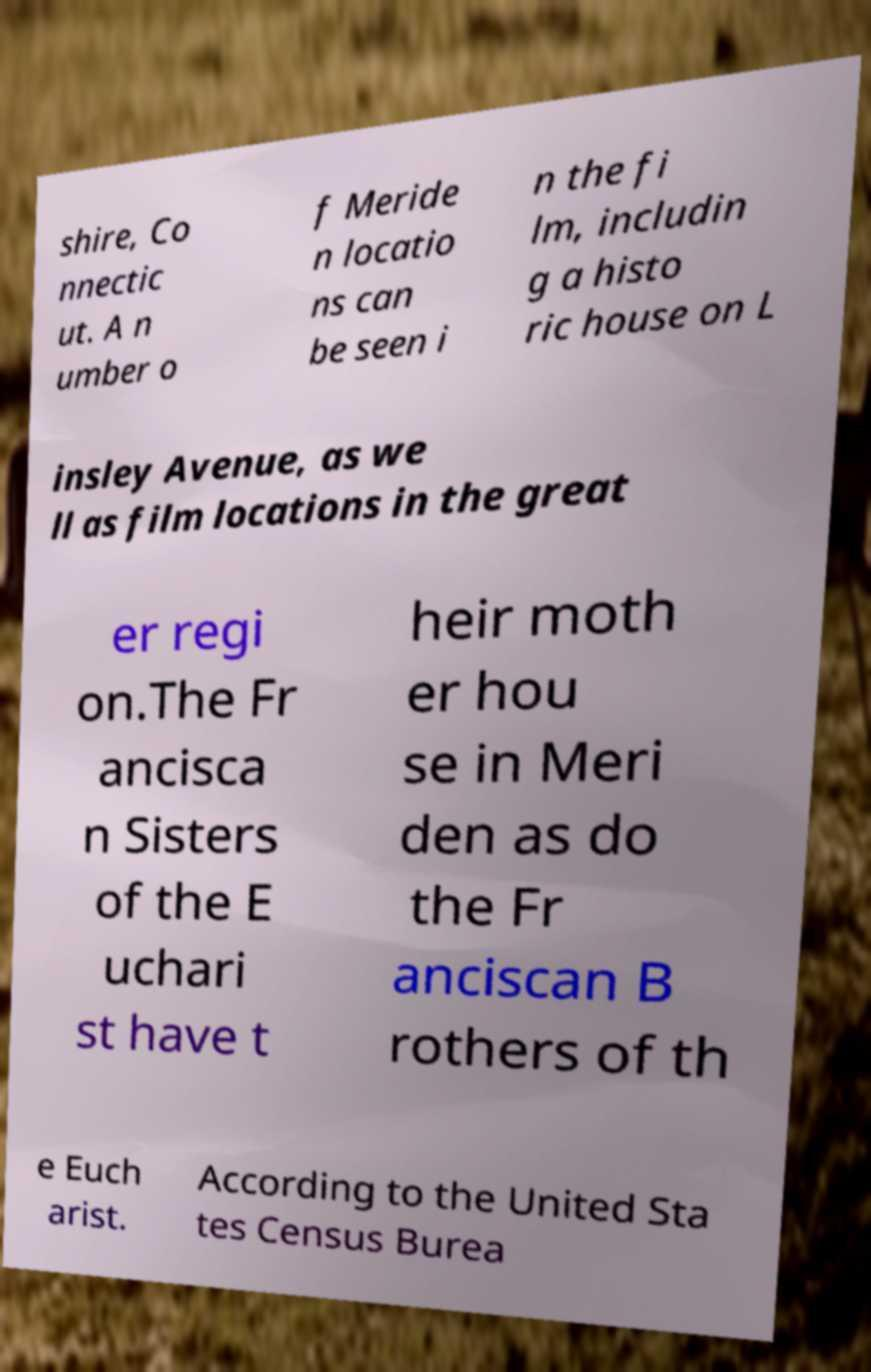Could you assist in decoding the text presented in this image and type it out clearly? shire, Co nnectic ut. A n umber o f Meride n locatio ns can be seen i n the fi lm, includin g a histo ric house on L insley Avenue, as we ll as film locations in the great er regi on.The Fr ancisca n Sisters of the E uchari st have t heir moth er hou se in Meri den as do the Fr anciscan B rothers of th e Euch arist. According to the United Sta tes Census Burea 